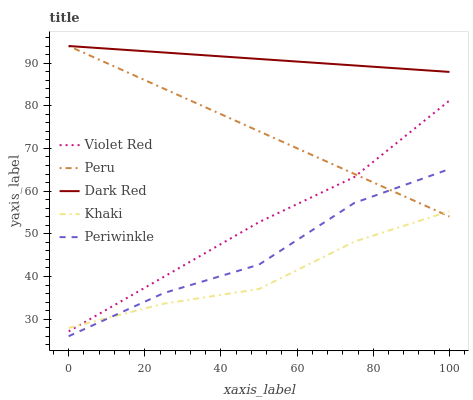Does Khaki have the minimum area under the curve?
Answer yes or no. Yes. Does Dark Red have the maximum area under the curve?
Answer yes or no. Yes. Does Violet Red have the minimum area under the curve?
Answer yes or no. No. Does Violet Red have the maximum area under the curve?
Answer yes or no. No. Is Peru the smoothest?
Answer yes or no. Yes. Is Periwinkle the roughest?
Answer yes or no. Yes. Is Violet Red the smoothest?
Answer yes or no. No. Is Violet Red the roughest?
Answer yes or no. No. Does Periwinkle have the lowest value?
Answer yes or no. Yes. Does Violet Red have the lowest value?
Answer yes or no. No. Does Peru have the highest value?
Answer yes or no. Yes. Does Violet Red have the highest value?
Answer yes or no. No. Is Khaki less than Dark Red?
Answer yes or no. Yes. Is Dark Red greater than Violet Red?
Answer yes or no. Yes. Does Peru intersect Khaki?
Answer yes or no. Yes. Is Peru less than Khaki?
Answer yes or no. No. Is Peru greater than Khaki?
Answer yes or no. No. Does Khaki intersect Dark Red?
Answer yes or no. No. 